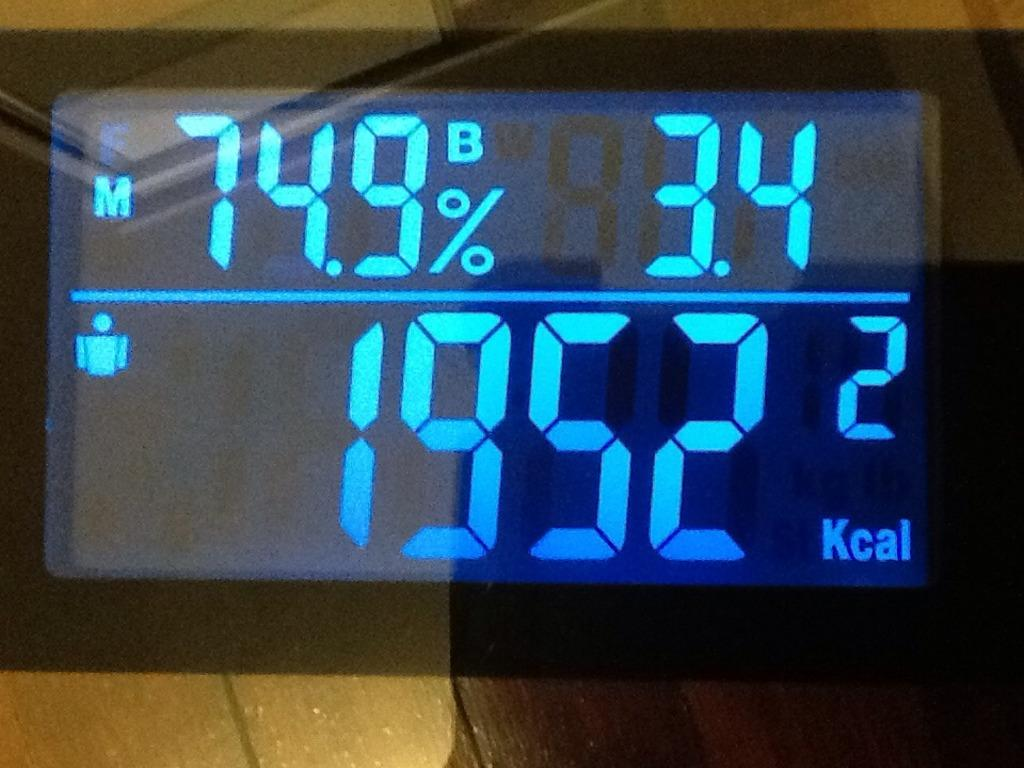Provide a one-sentence caption for the provided image. a screen displaying 1952 Kcal in bright blue on a black background. 